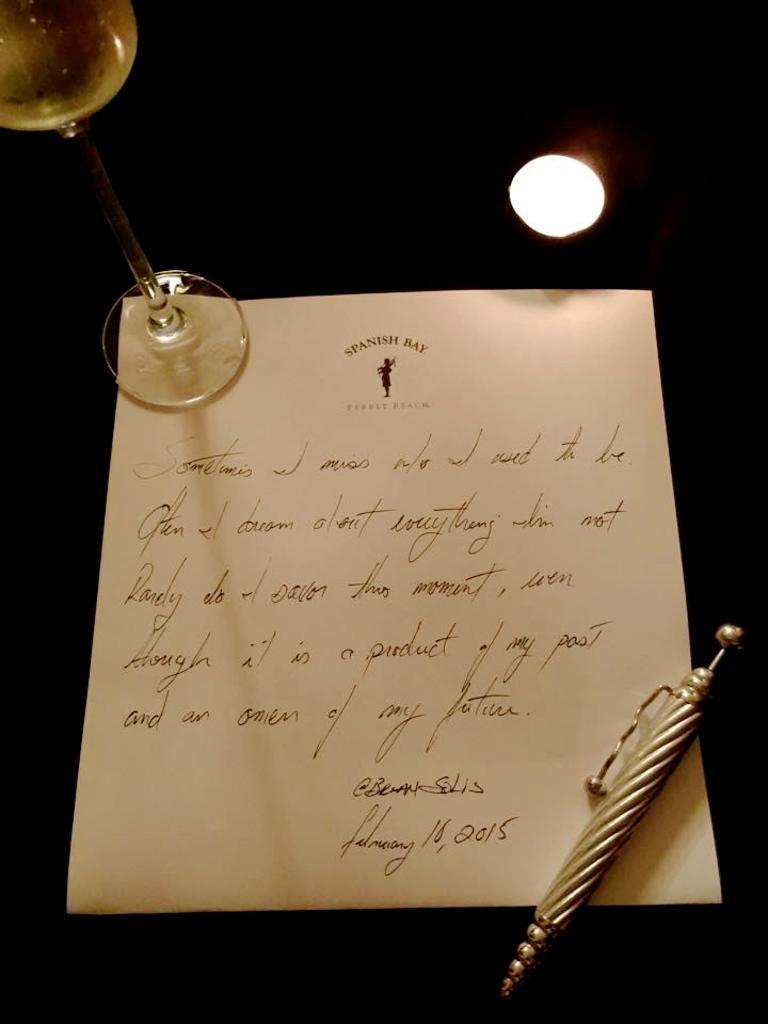Describe this image in one or two sentences. In this image I can see the pen, paper and the glass. In the background I can see the light. 